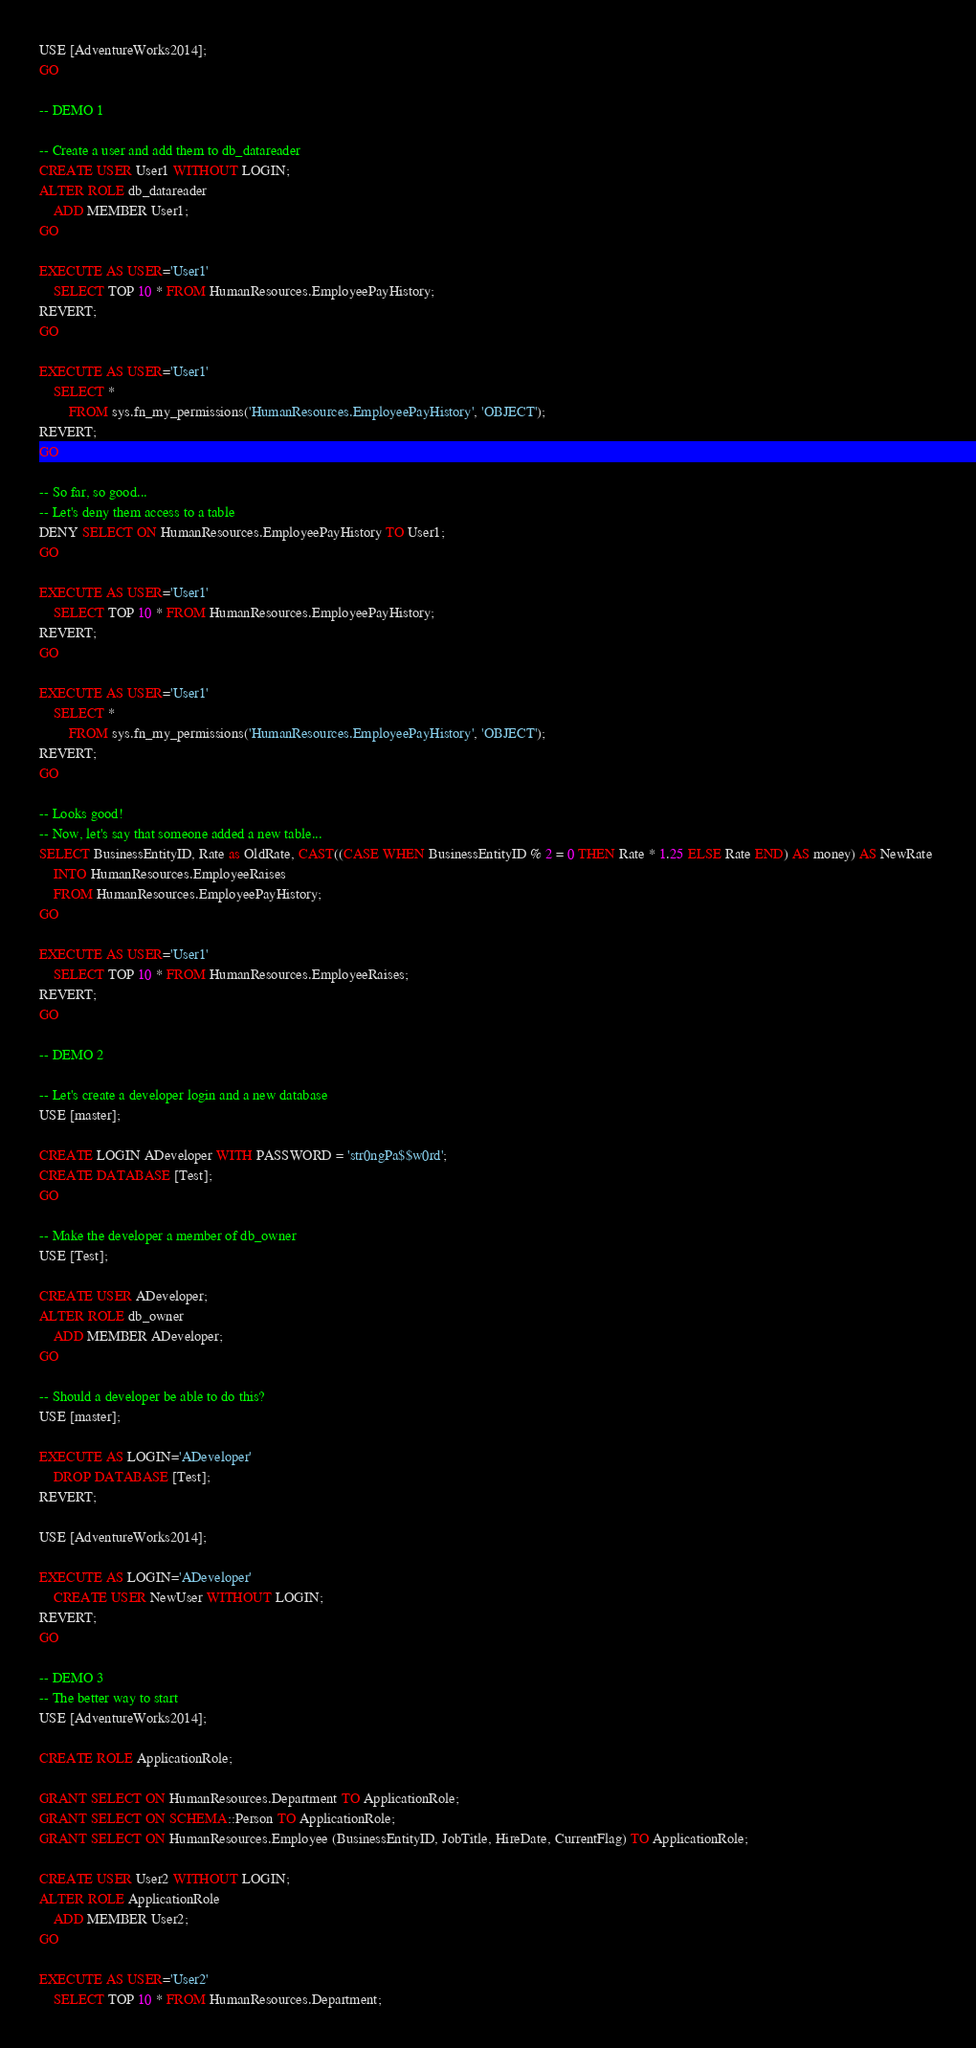<code> <loc_0><loc_0><loc_500><loc_500><_SQL_>USE [AdventureWorks2014];
GO

-- DEMO 1

-- Create a user and add them to db_datareader
CREATE USER User1 WITHOUT LOGIN;
ALTER ROLE db_datareader
	ADD MEMBER User1;
GO

EXECUTE AS USER='User1'
	SELECT TOP 10 * FROM HumanResources.EmployeePayHistory;
REVERT;
GO

EXECUTE AS USER='User1'
	SELECT *
		FROM sys.fn_my_permissions('HumanResources.EmployeePayHistory', 'OBJECT');
REVERT;
GO

-- So far, so good...
-- Let's deny them access to a table
DENY SELECT ON HumanResources.EmployeePayHistory TO User1;
GO

EXECUTE AS USER='User1'
	SELECT TOP 10 * FROM HumanResources.EmployeePayHistory;
REVERT;
GO

EXECUTE AS USER='User1'
	SELECT *
		FROM sys.fn_my_permissions('HumanResources.EmployeePayHistory', 'OBJECT');
REVERT;
GO

-- Looks good!
-- Now, let's say that someone added a new table...
SELECT BusinessEntityID, Rate as OldRate, CAST((CASE WHEN BusinessEntityID % 2 = 0 THEN Rate * 1.25 ELSE Rate END) AS money) AS NewRate 
	INTO HumanResources.EmployeeRaises
	FROM HumanResources.EmployeePayHistory;
GO

EXECUTE AS USER='User1'
	SELECT TOP 10 * FROM HumanResources.EmployeeRaises;
REVERT;
GO

-- DEMO 2

-- Let's create a developer login and a new database
USE [master];

CREATE LOGIN ADeveloper WITH PASSWORD = 'str0ngPa$$w0rd';
CREATE DATABASE [Test];
GO

-- Make the developer a member of db_owner
USE [Test];

CREATE USER ADeveloper;
ALTER ROLE db_owner
	ADD MEMBER ADeveloper;
GO

-- Should a developer be able to do this?
USE [master];

EXECUTE AS LOGIN='ADeveloper'
	DROP DATABASE [Test];
REVERT;

USE [AdventureWorks2014];

EXECUTE AS LOGIN='ADeveloper'
	CREATE USER NewUser WITHOUT LOGIN;
REVERT;
GO

-- DEMO 3
-- The better way to start
USE [AdventureWorks2014];

CREATE ROLE ApplicationRole;

GRANT SELECT ON HumanResources.Department TO ApplicationRole;
GRANT SELECT ON SCHEMA::Person TO ApplicationRole;
GRANT SELECT ON HumanResources.Employee (BusinessEntityID, JobTitle, HireDate, CurrentFlag) TO ApplicationRole;

CREATE USER User2 WITHOUT LOGIN;
ALTER ROLE ApplicationRole
	ADD MEMBER User2;
GO

EXECUTE AS USER='User2'
	SELECT TOP 10 * FROM HumanResources.Department;
</code> 